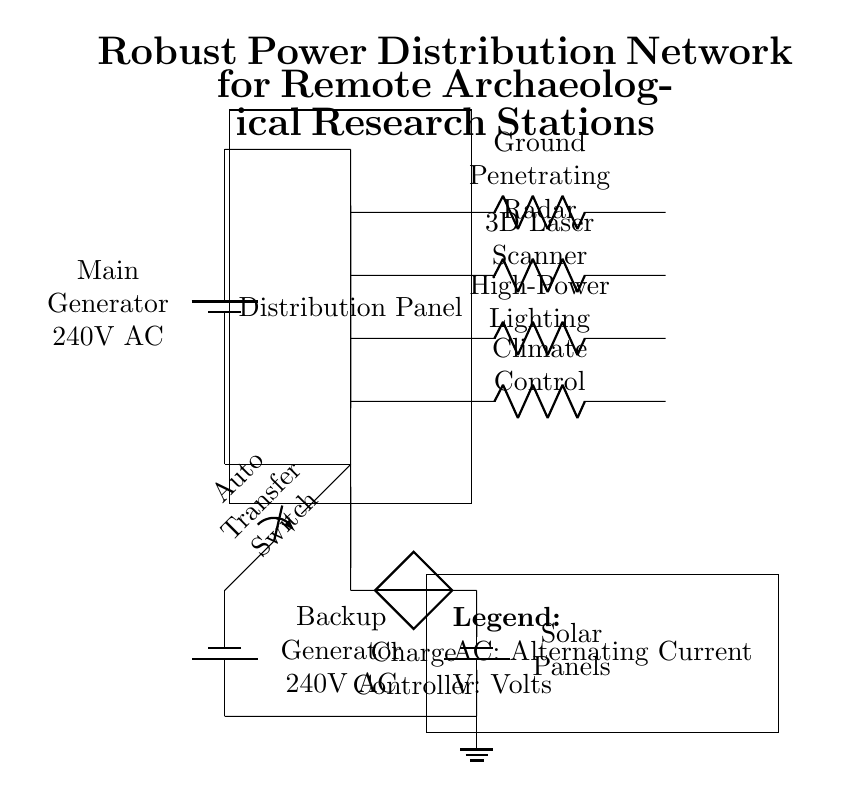What are the main power sources in this circuit? The circuit includes a main generator and a backup generator as the primary power sources. Both are labeled accordingly within the diagram.
Answer: main generator, backup generator Which high-power appliance is connected at the highest point in the circuit? The highest point in the circuit diagram is occupied by the ground penetrating radar, which is drawn at the topmost connection in the distribution panel section.
Answer: Ground Penetrating Radar What is the function of the auto transfer switch in this circuit? The auto transfer switch's function is to switch between the main generator and the backup generator automatically when a power outage occurs, ensuring continuous power supply.
Answer: switch power sources What is the total number of high-power appliances depicted in the circuit? To find the total number of high-power appliances, count each individual appliance drawn in the circuit, which shows four appliances listed under the distribution panel.
Answer: four How does the backup generator recharge the distribution network? The backup generator is linked to the distribution panel through an auto transfer switch, allowing it to provide power to the network whenever there is a failure in the main source, ensuring reliability.
Answer: via auto transfer switch Which component types implement renewable energy in this circuit? The renewable energy components are the solar panels and the charge controller. They are specifically mentioned and positioned in the lower part of the circuit diagram.
Answer: solar panels, charge controller 